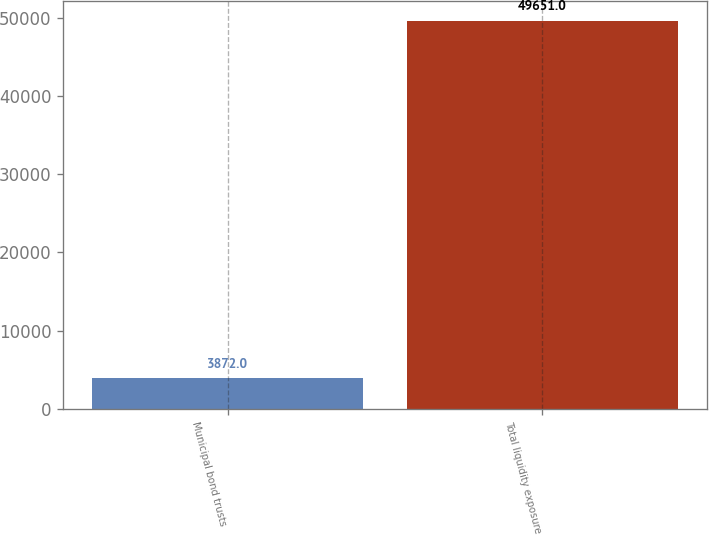Convert chart to OTSL. <chart><loc_0><loc_0><loc_500><loc_500><bar_chart><fcel>Municipal bond trusts<fcel>Total liquidity exposure<nl><fcel>3872<fcel>49651<nl></chart> 